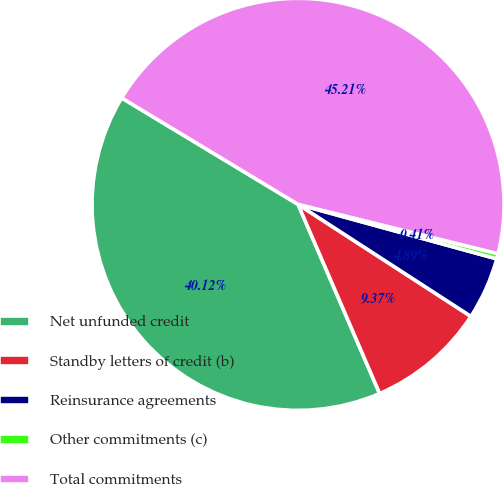Convert chart. <chart><loc_0><loc_0><loc_500><loc_500><pie_chart><fcel>Net unfunded credit<fcel>Standby letters of credit (b)<fcel>Reinsurance agreements<fcel>Other commitments (c)<fcel>Total commitments<nl><fcel>40.12%<fcel>9.37%<fcel>4.89%<fcel>0.41%<fcel>45.21%<nl></chart> 